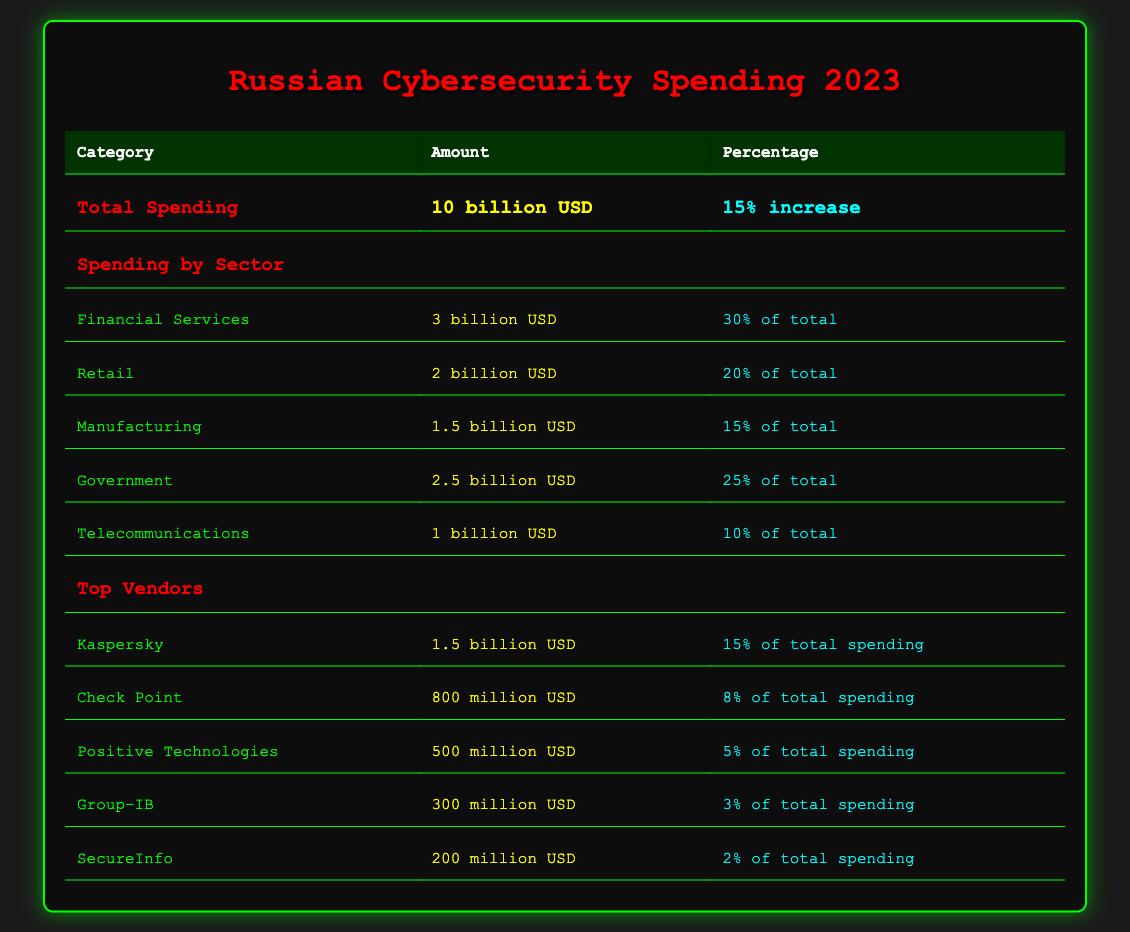What is the total cybersecurity spending in 2023? The table shows that the total spending for cybersecurity in 2023 is 10 billion USD.
Answer: 10 billion USD Which sector has the highest spending in cybersecurity? From the table, the financial services sector has the highest spending at 3 billion USD, which is 30% of the total.
Answer: Financial Services What percentage of total spending is allocated to government cybersecurity? According to the table, government spending amounts to 2.5 billion USD, which represents 25% of the total cybersecurity spending.
Answer: 25% What is the combined spending of the top three vendors? The top three vendors are Kaspersky (1.5 billion USD), Check Point (800 million USD), and Positive Technologies (500 million USD). Adding these amounts gives 1.5 + 0.8 + 0.5 = 2.8 billion USD.
Answer: 2.8 billion USD Is the spending on telecommunications higher than that on manufacturing? The table shows telecom spending is 1 billion USD and manufacturing spending is 1.5 billion USD. Since 1 billion is less than 1.5 billion, the statement is false.
Answer: No What is the percentage increase in total cybersecurity spending from the previous year? The table indicates a 15% increase in total cybersecurity spending in 2023 compared to the previous year.
Answer: 15% Which sector's spending constitutes the smallest percentage of total cybersecurity spending? The telecommunications sector has spending of 1 billion USD, constituting 10% of the total, which is smaller than all other sectors listed.
Answer: Telecommunications If the spending on retail cybersecurity increases by 10%, what will the new amount be? Retail spending is currently 2 billion USD. A 10% increase would be calculated as 2 billion USD + (10% of 2 billion USD) = 2 billion USD + 0.2 billion USD = 2.2 billion USD.
Answer: 2.2 billion USD How much does SecureInfo contribute to the total cybersecurity spending as a percentage? SecureInfo's spending of 200 million USD constitutes 2% of the total spending according to the table.
Answer: 2% 